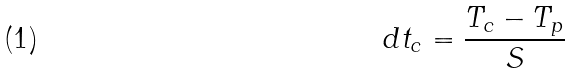Convert formula to latex. <formula><loc_0><loc_0><loc_500><loc_500>d t _ { c } = \frac { T _ { c } - T _ { p } } { S }</formula> 